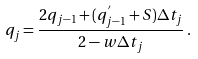<formula> <loc_0><loc_0><loc_500><loc_500>q _ { j } = \frac { 2 q _ { j - 1 } + ( q ^ { ^ { \prime } } _ { j - 1 } + S ) \Delta t _ { j } } { 2 - w \Delta t _ { j } } \, .</formula> 